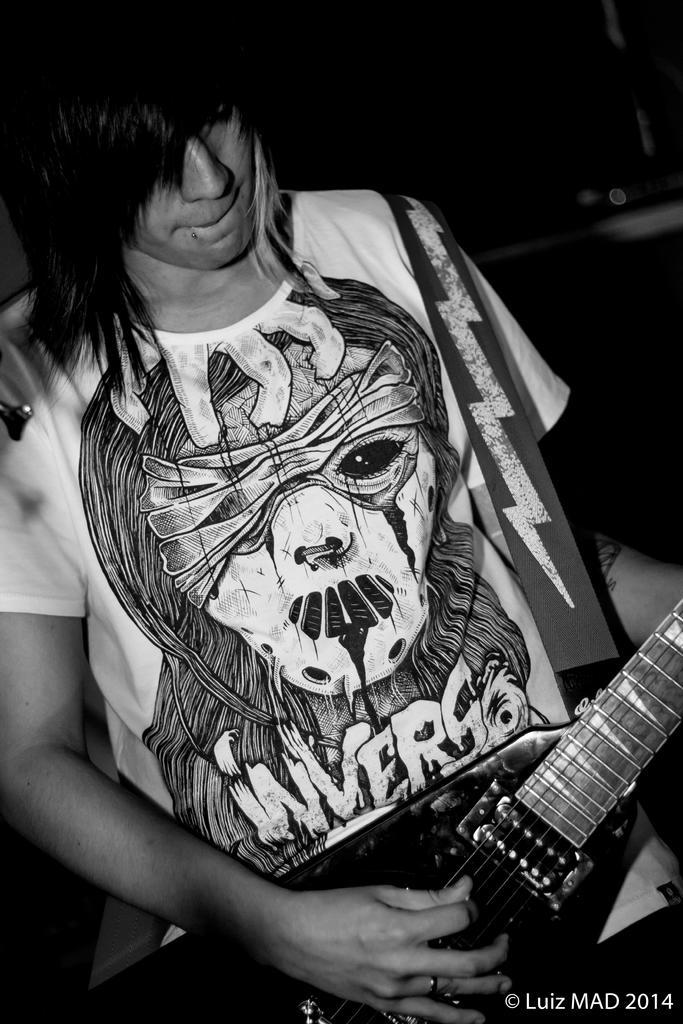In one or two sentences, can you explain what this image depicts? In this picture we can see a man who is playing guitar. 